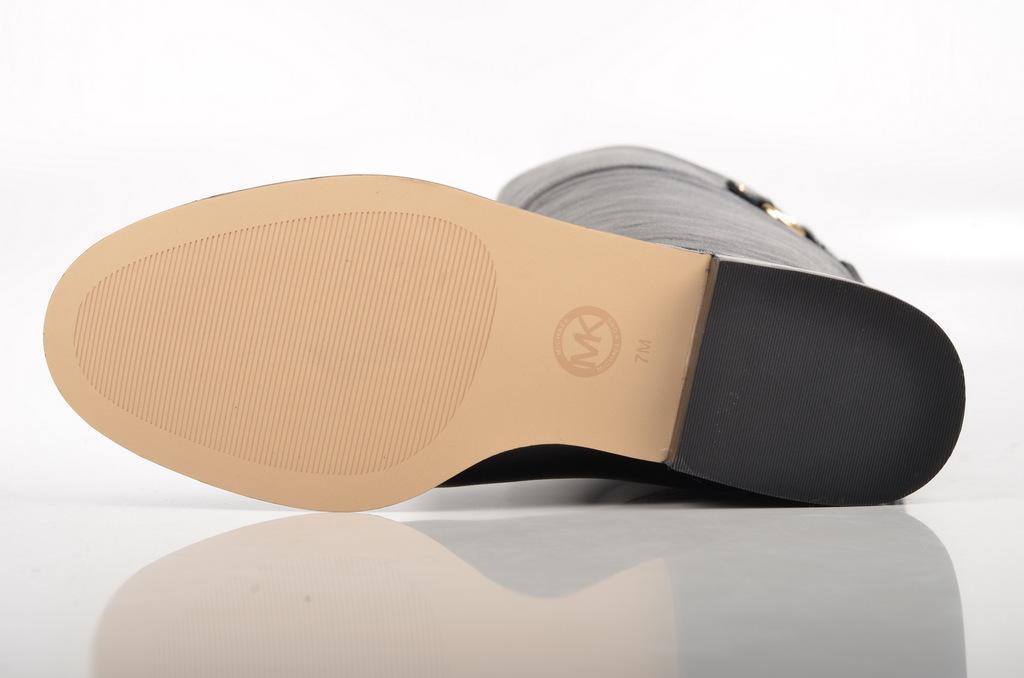Can you describe this image briefly? In this image I can see a sole of a shoe. There is a white background. 